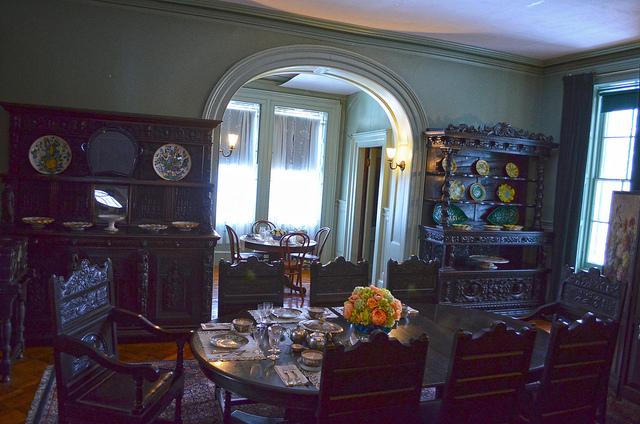What are the two pieces of furniture on either side of the doorway called?
Concise answer only. China cabinets. How many tables are in the picture?
Quick response, please. 2. What kind of windows are at the back top?
Answer briefly. Glass. What type of dishes are on the shelves?
Short answer required. Plates. 